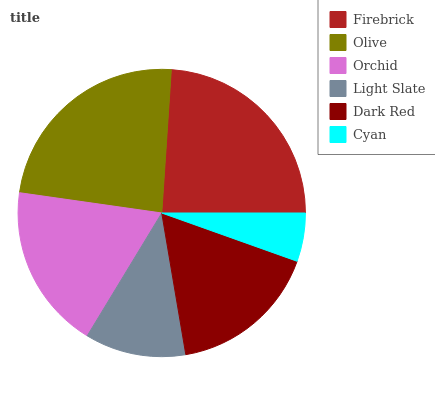Is Cyan the minimum?
Answer yes or no. Yes. Is Firebrick the maximum?
Answer yes or no. Yes. Is Olive the minimum?
Answer yes or no. No. Is Olive the maximum?
Answer yes or no. No. Is Firebrick greater than Olive?
Answer yes or no. Yes. Is Olive less than Firebrick?
Answer yes or no. Yes. Is Olive greater than Firebrick?
Answer yes or no. No. Is Firebrick less than Olive?
Answer yes or no. No. Is Orchid the high median?
Answer yes or no. Yes. Is Dark Red the low median?
Answer yes or no. Yes. Is Firebrick the high median?
Answer yes or no. No. Is Firebrick the low median?
Answer yes or no. No. 